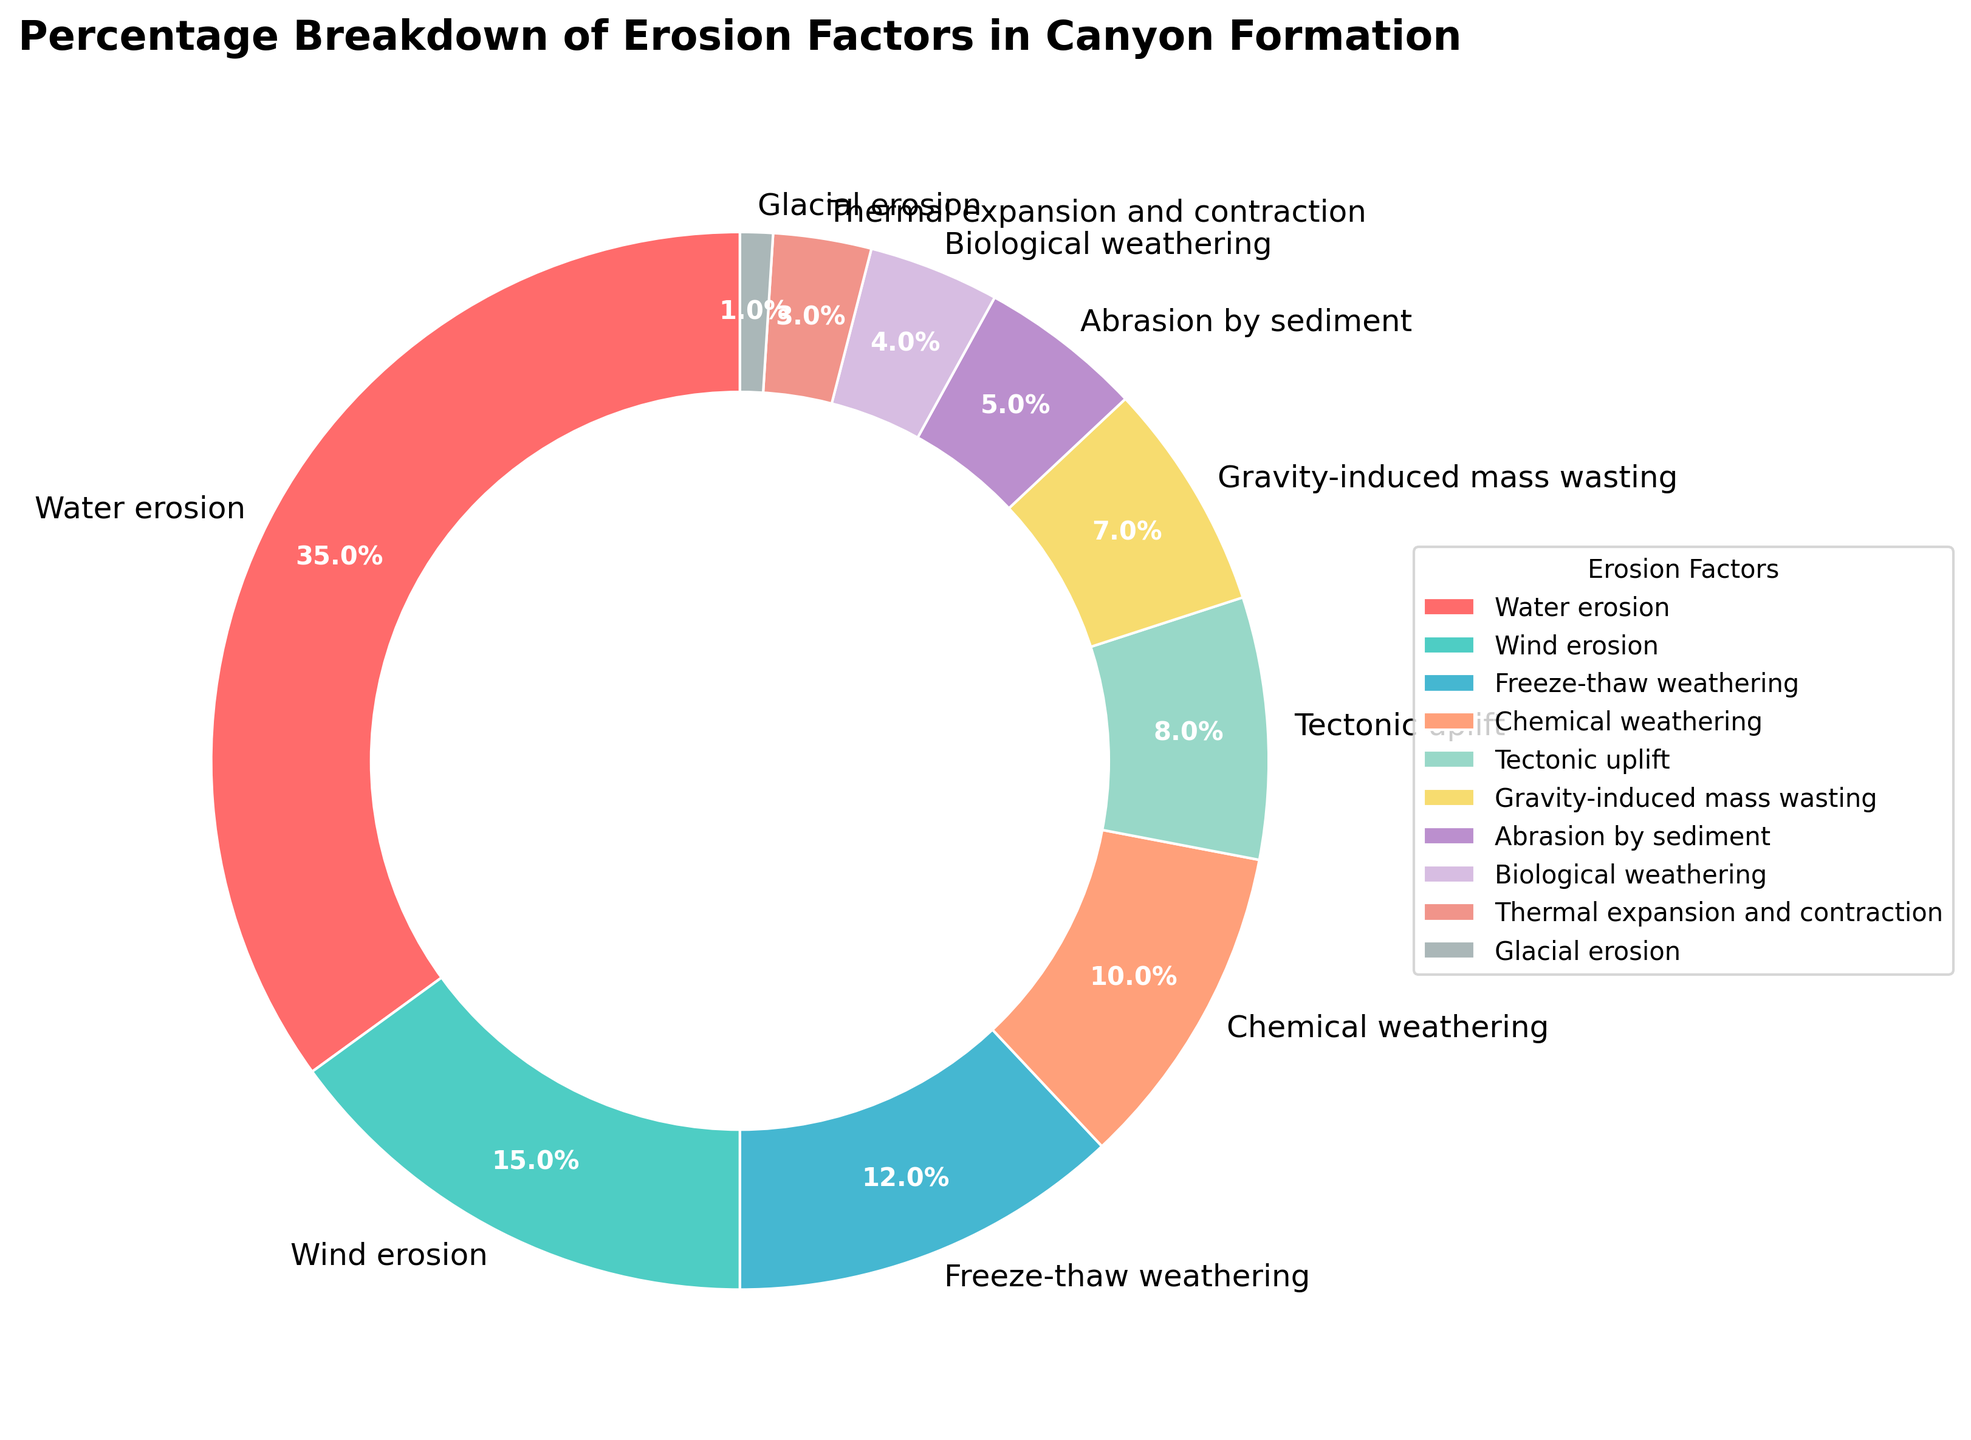What percentage of canyon formation is due to water erosion and wind erosion combined? To find this, we need to add the percentages of water erosion and wind erosion. Water erosion contributes 35% and wind erosion contributes 15%. Adding these values gives 35 + 15 = 50%.
Answer: 50% Which erosion factor contributes the least to canyon formation? The pie chart shows the smallest segment representing glacial erosion with a percentage of 1%.
Answer: Glacial erosion How much more does water erosion contribute to canyon formation compared to chemical weathering? Water erosion is 35%, and chemical weathering is 10%. The difference is 35 - 10 = 25%.
Answer: 25% Order the erosion factors from the highest to the lowest contribution to canyon formation. Based on the pie chart, the order from highest to lowest contribution is: Water erosion, Wind erosion, Freeze-thaw weathering, Chemical weathering, Tectonic uplift, Gravity-induced mass wasting, Abrasion by sediment, Biological weathering, Thermal expansion and contraction, and Glacial erosion.
Answer: Water erosion, Wind erosion, Freeze-thaw weathering, Chemical weathering, Tectonic uplift, Gravity-induced mass wasting, Abrasion by sediment, Biological weathering, Thermal expansion and contraction, Glacial erosion What is the combined percentage of erosion factors contributing less than 10% each to canyon formation? Factors contributing less than 10% are Tectonic uplift (8%), Gravity-induced mass wasting (7%), Abrasion by sediment (5%), Biological weathering (4%), Thermal expansion and contraction (3%), and Glacial erosion (1%). Adding these percentages, we get 8 + 7 + 5 + 4 + 3 + 1 = 28%.
Answer: 28% Which erosion factors fall within the same color family on the pie chart? The pie chart uses distinct colors for each segment, but visually similar colors might be identified. For instance, Abrasion by sediment (light purple) and Biological weathering (light pink) appear within the same color palette.
Answer: Abrasion by sediment and Biological weathering What percentage of canyon formation is due to freeze-thaw weathering and biological weathering combined? Freeze-thaw weathering contributes 12% and biological weathering contributes 4%. Adding these gives 12 + 4 = 16%.
Answer: 16% How does the percentage contribution of tectonic uplift compare to that of water erosion? Tectonic uplift contributes 8%, and water erosion contributes 35%. Water erosion significantly outweighs tectonic uplift by 35 - 8 = 27%.
Answer: Water erosion is 27% higher What fraction of the total does wind erosion represent? Wind erosion contributes 15%, which can be expressed as a fraction by dividing by 100. So, 15/100 is equal to 3/20.
Answer: 3/20 Which factor has a closer percentage contribution to gravity-induced mass wasting, thermal expansion and contraction, or freeze-thaw weathering? Gravity-induced mass wasting contributes 7%. Thermal expansion and contraction (3%) is further away, while freeze-thaw weathering (12%) is closer by comparison. The difference is 12 - 7 = 5% for freeze-thaw and 7 - 3 = 4% for thermal expansion, but the direction reflects freeze-thaw is closer when considering magnitude.
Answer: Freeze-thaw weathering 